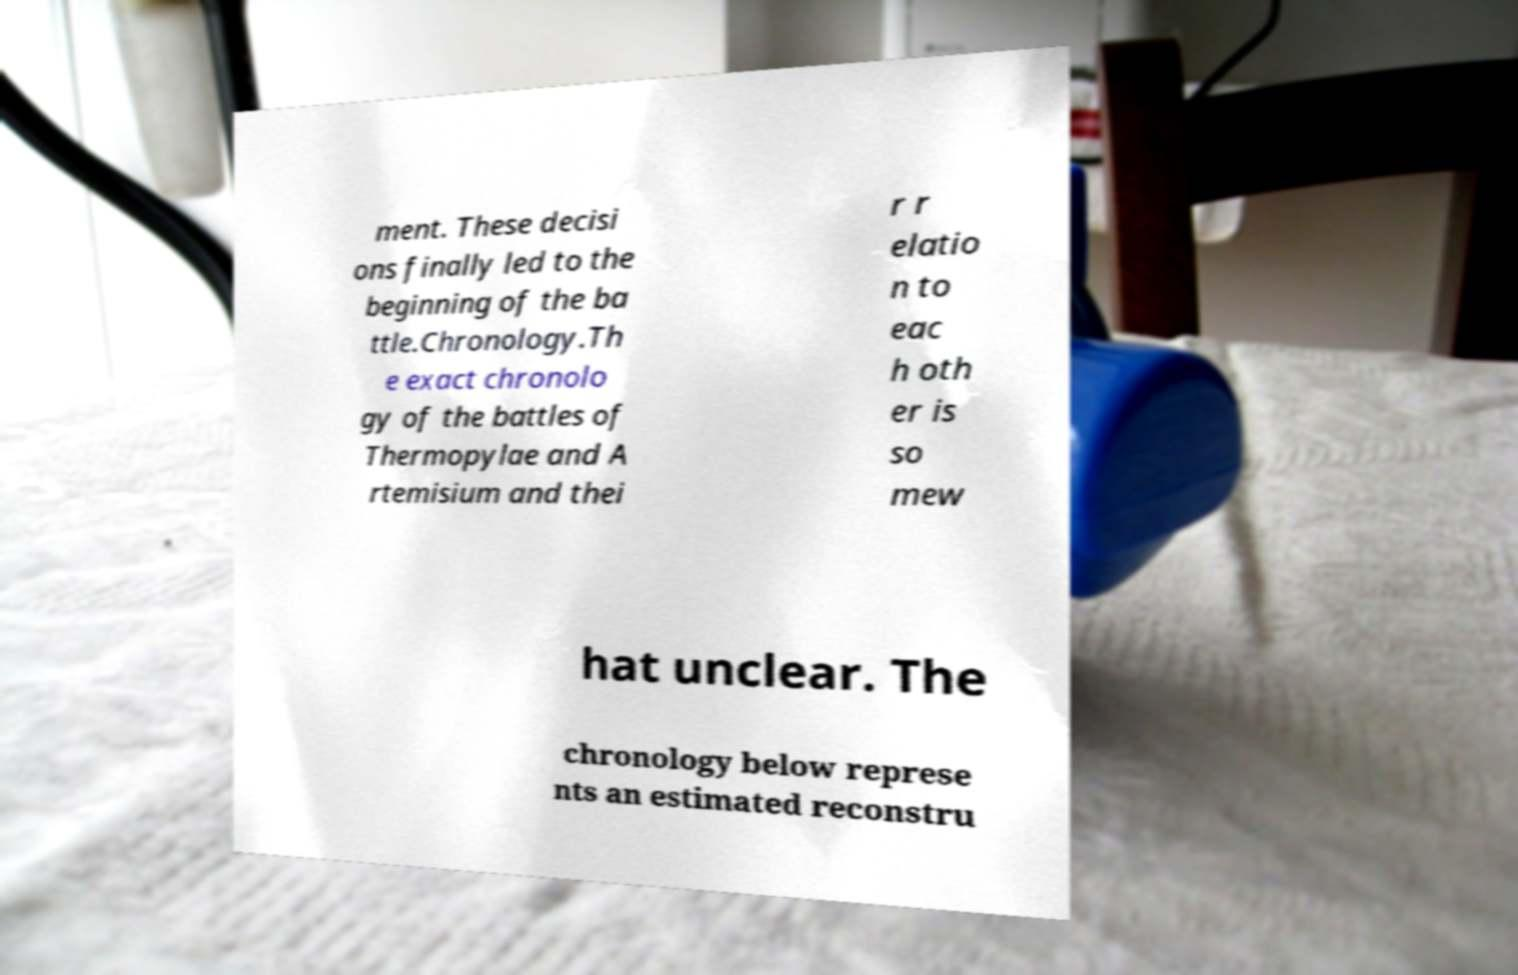There's text embedded in this image that I need extracted. Can you transcribe it verbatim? ment. These decisi ons finally led to the beginning of the ba ttle.Chronology.Th e exact chronolo gy of the battles of Thermopylae and A rtemisium and thei r r elatio n to eac h oth er is so mew hat unclear. The chronology below represe nts an estimated reconstru 